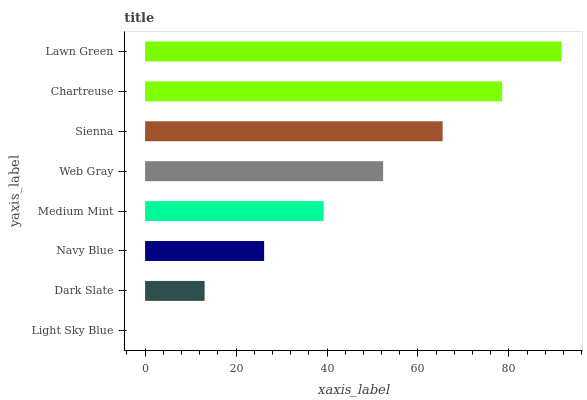Is Light Sky Blue the minimum?
Answer yes or no. Yes. Is Lawn Green the maximum?
Answer yes or no. Yes. Is Dark Slate the minimum?
Answer yes or no. No. Is Dark Slate the maximum?
Answer yes or no. No. Is Dark Slate greater than Light Sky Blue?
Answer yes or no. Yes. Is Light Sky Blue less than Dark Slate?
Answer yes or no. Yes. Is Light Sky Blue greater than Dark Slate?
Answer yes or no. No. Is Dark Slate less than Light Sky Blue?
Answer yes or no. No. Is Web Gray the high median?
Answer yes or no. Yes. Is Medium Mint the low median?
Answer yes or no. Yes. Is Dark Slate the high median?
Answer yes or no. No. Is Web Gray the low median?
Answer yes or no. No. 